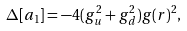Convert formula to latex. <formula><loc_0><loc_0><loc_500><loc_500>\Delta [ a _ { 1 } ] = - 4 ( g _ { u } ^ { 2 } + g _ { d } ^ { 2 } ) g ( r ) ^ { 2 } ,</formula> 